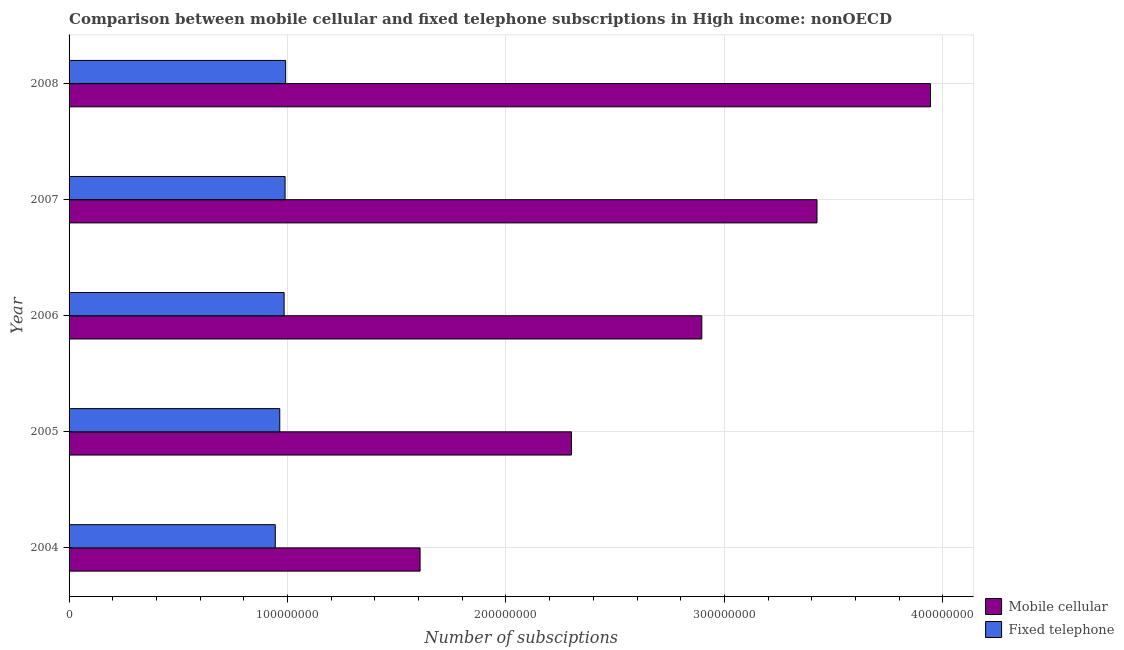How many different coloured bars are there?
Provide a short and direct response. 2. Are the number of bars per tick equal to the number of legend labels?
Give a very brief answer. Yes. Are the number of bars on each tick of the Y-axis equal?
Keep it short and to the point. Yes. How many bars are there on the 5th tick from the top?
Make the answer very short. 2. What is the label of the 3rd group of bars from the top?
Make the answer very short. 2006. What is the number of mobile cellular subscriptions in 2004?
Your response must be concise. 1.61e+08. Across all years, what is the maximum number of fixed telephone subscriptions?
Your response must be concise. 9.91e+07. Across all years, what is the minimum number of mobile cellular subscriptions?
Offer a terse response. 1.61e+08. In which year was the number of fixed telephone subscriptions minimum?
Ensure brevity in your answer.  2004. What is the total number of fixed telephone subscriptions in the graph?
Make the answer very short. 4.87e+08. What is the difference between the number of mobile cellular subscriptions in 2004 and that in 2006?
Provide a succinct answer. -1.29e+08. What is the difference between the number of fixed telephone subscriptions in 2008 and the number of mobile cellular subscriptions in 2007?
Provide a short and direct response. -2.43e+08. What is the average number of fixed telephone subscriptions per year?
Your response must be concise. 9.75e+07. In the year 2007, what is the difference between the number of mobile cellular subscriptions and number of fixed telephone subscriptions?
Offer a terse response. 2.43e+08. In how many years, is the number of fixed telephone subscriptions greater than 380000000 ?
Offer a very short reply. 0. What is the ratio of the number of mobile cellular subscriptions in 2004 to that in 2005?
Keep it short and to the point. 0.7. What is the difference between the highest and the second highest number of mobile cellular subscriptions?
Keep it short and to the point. 5.20e+07. What is the difference between the highest and the lowest number of mobile cellular subscriptions?
Your answer should be very brief. 2.34e+08. In how many years, is the number of fixed telephone subscriptions greater than the average number of fixed telephone subscriptions taken over all years?
Provide a succinct answer. 3. Is the sum of the number of mobile cellular subscriptions in 2005 and 2006 greater than the maximum number of fixed telephone subscriptions across all years?
Ensure brevity in your answer.  Yes. What does the 1st bar from the top in 2007 represents?
Your response must be concise. Fixed telephone. What does the 2nd bar from the bottom in 2004 represents?
Provide a short and direct response. Fixed telephone. How many bars are there?
Make the answer very short. 10. Are all the bars in the graph horizontal?
Provide a succinct answer. Yes. Does the graph contain any zero values?
Offer a very short reply. No. Where does the legend appear in the graph?
Your answer should be very brief. Bottom right. What is the title of the graph?
Make the answer very short. Comparison between mobile cellular and fixed telephone subscriptions in High income: nonOECD. Does "Taxes" appear as one of the legend labels in the graph?
Offer a terse response. No. What is the label or title of the X-axis?
Offer a terse response. Number of subsciptions. What is the label or title of the Y-axis?
Provide a short and direct response. Year. What is the Number of subsciptions of Mobile cellular in 2004?
Your answer should be compact. 1.61e+08. What is the Number of subsciptions in Fixed telephone in 2004?
Your answer should be compact. 9.44e+07. What is the Number of subsciptions in Mobile cellular in 2005?
Your answer should be compact. 2.30e+08. What is the Number of subsciptions of Fixed telephone in 2005?
Ensure brevity in your answer.  9.65e+07. What is the Number of subsciptions of Mobile cellular in 2006?
Ensure brevity in your answer.  2.90e+08. What is the Number of subsciptions of Fixed telephone in 2006?
Your answer should be compact. 9.84e+07. What is the Number of subsciptions in Mobile cellular in 2007?
Provide a succinct answer. 3.42e+08. What is the Number of subsciptions of Fixed telephone in 2007?
Provide a short and direct response. 9.89e+07. What is the Number of subsciptions in Mobile cellular in 2008?
Make the answer very short. 3.94e+08. What is the Number of subsciptions of Fixed telephone in 2008?
Provide a succinct answer. 9.91e+07. Across all years, what is the maximum Number of subsciptions in Mobile cellular?
Offer a terse response. 3.94e+08. Across all years, what is the maximum Number of subsciptions of Fixed telephone?
Provide a short and direct response. 9.91e+07. Across all years, what is the minimum Number of subsciptions in Mobile cellular?
Provide a short and direct response. 1.61e+08. Across all years, what is the minimum Number of subsciptions of Fixed telephone?
Ensure brevity in your answer.  9.44e+07. What is the total Number of subsciptions of Mobile cellular in the graph?
Your answer should be compact. 1.42e+09. What is the total Number of subsciptions in Fixed telephone in the graph?
Provide a short and direct response. 4.87e+08. What is the difference between the Number of subsciptions of Mobile cellular in 2004 and that in 2005?
Offer a terse response. -6.93e+07. What is the difference between the Number of subsciptions in Fixed telephone in 2004 and that in 2005?
Keep it short and to the point. -2.05e+06. What is the difference between the Number of subsciptions in Mobile cellular in 2004 and that in 2006?
Provide a short and direct response. -1.29e+08. What is the difference between the Number of subsciptions in Fixed telephone in 2004 and that in 2006?
Your answer should be compact. -4.04e+06. What is the difference between the Number of subsciptions in Mobile cellular in 2004 and that in 2007?
Keep it short and to the point. -1.82e+08. What is the difference between the Number of subsciptions of Fixed telephone in 2004 and that in 2007?
Keep it short and to the point. -4.48e+06. What is the difference between the Number of subsciptions of Mobile cellular in 2004 and that in 2008?
Offer a terse response. -2.34e+08. What is the difference between the Number of subsciptions in Fixed telephone in 2004 and that in 2008?
Offer a terse response. -4.73e+06. What is the difference between the Number of subsciptions in Mobile cellular in 2005 and that in 2006?
Offer a terse response. -5.97e+07. What is the difference between the Number of subsciptions in Fixed telephone in 2005 and that in 2006?
Keep it short and to the point. -1.99e+06. What is the difference between the Number of subsciptions in Mobile cellular in 2005 and that in 2007?
Offer a very short reply. -1.12e+08. What is the difference between the Number of subsciptions of Fixed telephone in 2005 and that in 2007?
Provide a short and direct response. -2.43e+06. What is the difference between the Number of subsciptions in Mobile cellular in 2005 and that in 2008?
Your answer should be compact. -1.64e+08. What is the difference between the Number of subsciptions of Fixed telephone in 2005 and that in 2008?
Your answer should be compact. -2.68e+06. What is the difference between the Number of subsciptions in Mobile cellular in 2006 and that in 2007?
Make the answer very short. -5.27e+07. What is the difference between the Number of subsciptions in Fixed telephone in 2006 and that in 2007?
Provide a succinct answer. -4.41e+05. What is the difference between the Number of subsciptions in Mobile cellular in 2006 and that in 2008?
Your answer should be very brief. -1.05e+08. What is the difference between the Number of subsciptions of Fixed telephone in 2006 and that in 2008?
Offer a very short reply. -6.91e+05. What is the difference between the Number of subsciptions of Mobile cellular in 2007 and that in 2008?
Make the answer very short. -5.20e+07. What is the difference between the Number of subsciptions in Fixed telephone in 2007 and that in 2008?
Ensure brevity in your answer.  -2.50e+05. What is the difference between the Number of subsciptions in Mobile cellular in 2004 and the Number of subsciptions in Fixed telephone in 2005?
Ensure brevity in your answer.  6.42e+07. What is the difference between the Number of subsciptions of Mobile cellular in 2004 and the Number of subsciptions of Fixed telephone in 2006?
Your answer should be very brief. 6.22e+07. What is the difference between the Number of subsciptions of Mobile cellular in 2004 and the Number of subsciptions of Fixed telephone in 2007?
Keep it short and to the point. 6.18e+07. What is the difference between the Number of subsciptions of Mobile cellular in 2004 and the Number of subsciptions of Fixed telephone in 2008?
Offer a terse response. 6.15e+07. What is the difference between the Number of subsciptions in Mobile cellular in 2005 and the Number of subsciptions in Fixed telephone in 2006?
Give a very brief answer. 1.32e+08. What is the difference between the Number of subsciptions of Mobile cellular in 2005 and the Number of subsciptions of Fixed telephone in 2007?
Provide a succinct answer. 1.31e+08. What is the difference between the Number of subsciptions of Mobile cellular in 2005 and the Number of subsciptions of Fixed telephone in 2008?
Your response must be concise. 1.31e+08. What is the difference between the Number of subsciptions in Mobile cellular in 2006 and the Number of subsciptions in Fixed telephone in 2007?
Your answer should be very brief. 1.91e+08. What is the difference between the Number of subsciptions in Mobile cellular in 2006 and the Number of subsciptions in Fixed telephone in 2008?
Provide a short and direct response. 1.91e+08. What is the difference between the Number of subsciptions of Mobile cellular in 2007 and the Number of subsciptions of Fixed telephone in 2008?
Offer a very short reply. 2.43e+08. What is the average Number of subsciptions of Mobile cellular per year?
Ensure brevity in your answer.  2.83e+08. What is the average Number of subsciptions in Fixed telephone per year?
Give a very brief answer. 9.75e+07. In the year 2004, what is the difference between the Number of subsciptions in Mobile cellular and Number of subsciptions in Fixed telephone?
Provide a succinct answer. 6.63e+07. In the year 2005, what is the difference between the Number of subsciptions in Mobile cellular and Number of subsciptions in Fixed telephone?
Make the answer very short. 1.34e+08. In the year 2006, what is the difference between the Number of subsciptions in Mobile cellular and Number of subsciptions in Fixed telephone?
Your answer should be compact. 1.91e+08. In the year 2007, what is the difference between the Number of subsciptions of Mobile cellular and Number of subsciptions of Fixed telephone?
Your answer should be very brief. 2.43e+08. In the year 2008, what is the difference between the Number of subsciptions of Mobile cellular and Number of subsciptions of Fixed telephone?
Your answer should be very brief. 2.95e+08. What is the ratio of the Number of subsciptions of Mobile cellular in 2004 to that in 2005?
Your answer should be compact. 0.7. What is the ratio of the Number of subsciptions of Fixed telephone in 2004 to that in 2005?
Ensure brevity in your answer.  0.98. What is the ratio of the Number of subsciptions of Mobile cellular in 2004 to that in 2006?
Provide a succinct answer. 0.55. What is the ratio of the Number of subsciptions in Fixed telephone in 2004 to that in 2006?
Offer a very short reply. 0.96. What is the ratio of the Number of subsciptions of Mobile cellular in 2004 to that in 2007?
Your response must be concise. 0.47. What is the ratio of the Number of subsciptions in Fixed telephone in 2004 to that in 2007?
Provide a short and direct response. 0.95. What is the ratio of the Number of subsciptions in Mobile cellular in 2004 to that in 2008?
Offer a terse response. 0.41. What is the ratio of the Number of subsciptions in Fixed telephone in 2004 to that in 2008?
Offer a terse response. 0.95. What is the ratio of the Number of subsciptions of Mobile cellular in 2005 to that in 2006?
Your response must be concise. 0.79. What is the ratio of the Number of subsciptions of Fixed telephone in 2005 to that in 2006?
Your answer should be very brief. 0.98. What is the ratio of the Number of subsciptions of Mobile cellular in 2005 to that in 2007?
Offer a terse response. 0.67. What is the ratio of the Number of subsciptions of Fixed telephone in 2005 to that in 2007?
Provide a short and direct response. 0.98. What is the ratio of the Number of subsciptions of Mobile cellular in 2005 to that in 2008?
Keep it short and to the point. 0.58. What is the ratio of the Number of subsciptions of Mobile cellular in 2006 to that in 2007?
Keep it short and to the point. 0.85. What is the ratio of the Number of subsciptions of Fixed telephone in 2006 to that in 2007?
Your answer should be very brief. 1. What is the ratio of the Number of subsciptions in Mobile cellular in 2006 to that in 2008?
Ensure brevity in your answer.  0.73. What is the ratio of the Number of subsciptions of Mobile cellular in 2007 to that in 2008?
Offer a terse response. 0.87. What is the difference between the highest and the second highest Number of subsciptions in Mobile cellular?
Your answer should be very brief. 5.20e+07. What is the difference between the highest and the second highest Number of subsciptions of Fixed telephone?
Make the answer very short. 2.50e+05. What is the difference between the highest and the lowest Number of subsciptions of Mobile cellular?
Give a very brief answer. 2.34e+08. What is the difference between the highest and the lowest Number of subsciptions in Fixed telephone?
Keep it short and to the point. 4.73e+06. 